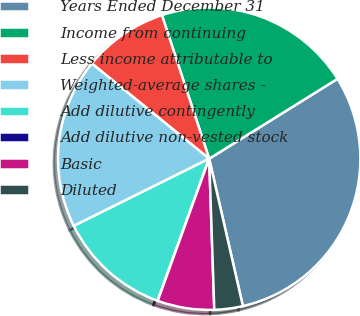Convert chart. <chart><loc_0><loc_0><loc_500><loc_500><pie_chart><fcel>Years Ended December 31<fcel>Income from continuing<fcel>Less income attributable to<fcel>Weighted-average shares -<fcel>Add dilutive contingently<fcel>Add dilutive non-vested stock<fcel>Basic<fcel>Diluted<nl><fcel>30.28%<fcel>21.2%<fcel>9.09%<fcel>18.18%<fcel>12.12%<fcel>0.01%<fcel>6.07%<fcel>3.04%<nl></chart> 